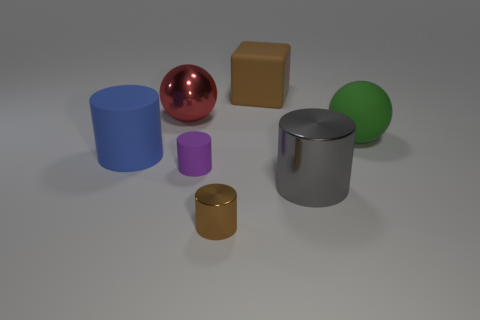What is the material of the large object that is the same color as the small metal thing?
Make the answer very short. Rubber. There is a ball on the right side of the big ball behind the big sphere that is right of the purple matte cylinder; what is it made of?
Your answer should be very brief. Rubber. There is a metal cylinder that is in front of the big gray metallic thing; does it have the same color as the big rubber block?
Ensure brevity in your answer.  Yes. The large object that is in front of the big green thing and to the right of the red thing is made of what material?
Offer a very short reply. Metal. Is there a cyan matte sphere that has the same size as the green rubber sphere?
Offer a terse response. No. How many large metallic things are there?
Your answer should be compact. 2. There is a gray metallic object; how many tiny metal cylinders are behind it?
Give a very brief answer. 0. Is the tiny purple cylinder made of the same material as the big gray thing?
Make the answer very short. No. How many big objects are both right of the rubber block and to the left of the brown shiny cylinder?
Provide a succinct answer. 0. What number of other things are there of the same color as the small metallic cylinder?
Offer a terse response. 1. 